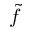<formula> <loc_0><loc_0><loc_500><loc_500>\tilde { f }</formula> 